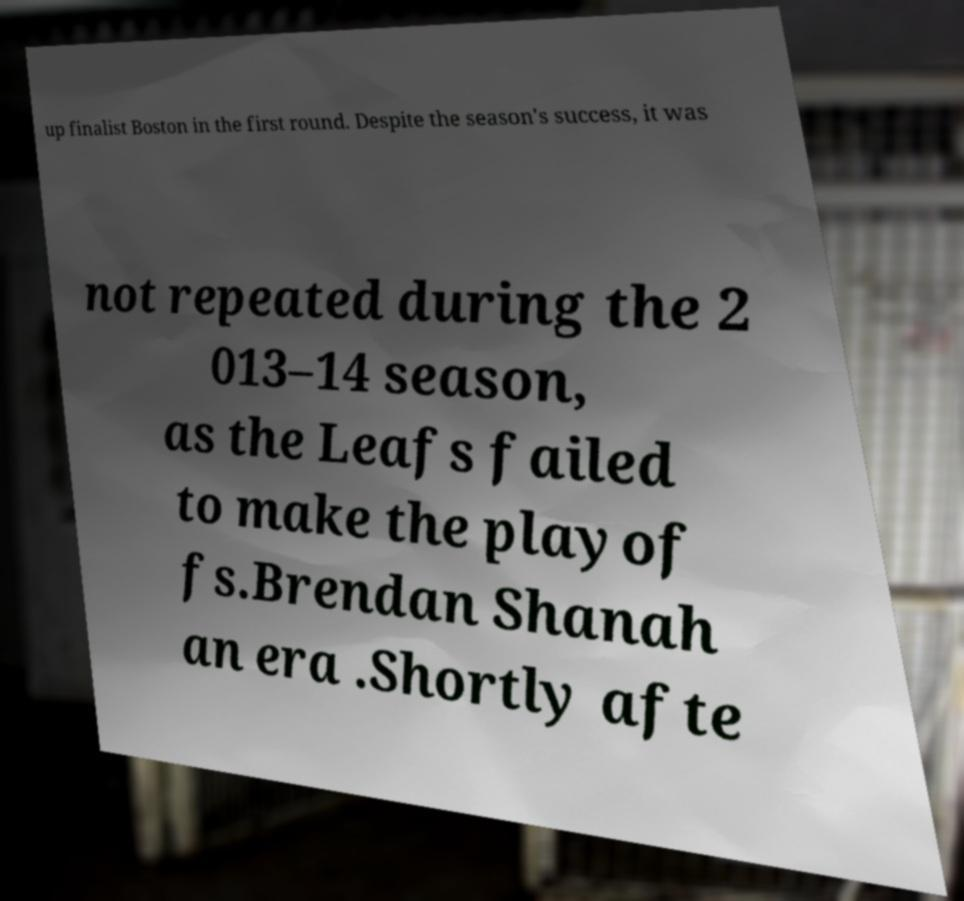Can you accurately transcribe the text from the provided image for me? up finalist Boston in the first round. Despite the season's success, it was not repeated during the 2 013–14 season, as the Leafs failed to make the playof fs.Brendan Shanah an era .Shortly afte 